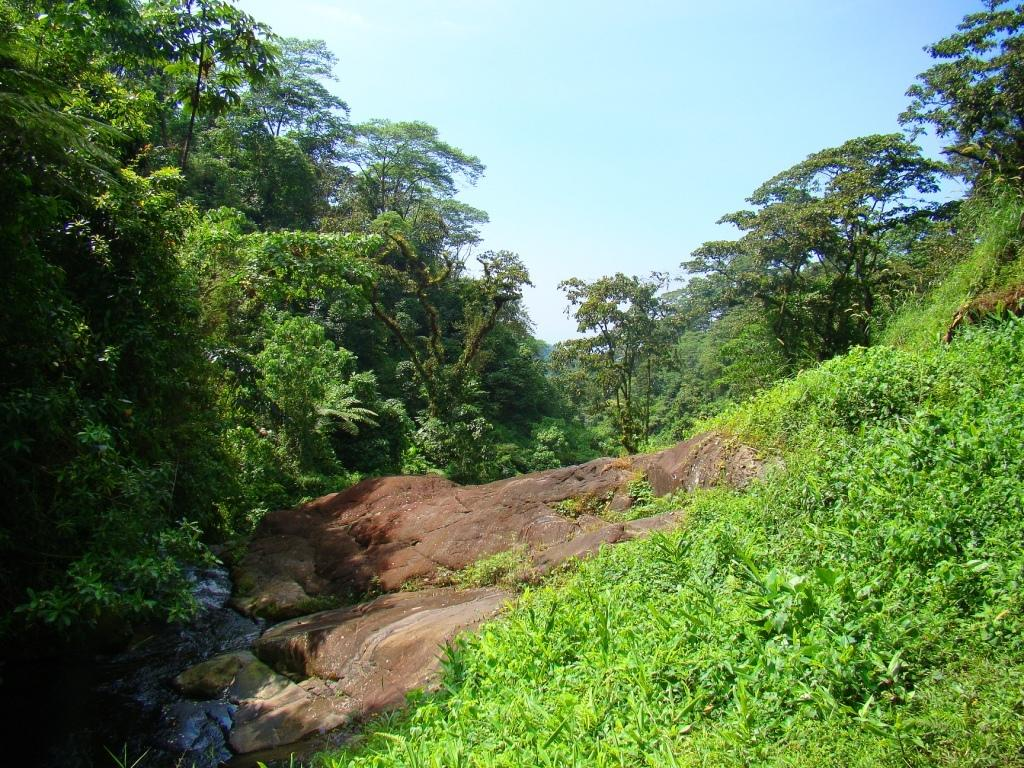What is located in the foreground of the image? There is stone and trees in the foreground of the image. What can be seen on the left side of the image? There appears to be water on the left side of the image. What is visible at the top of the image? The sky is visible at the top of the image. How many fans are visible in the image? There are no fans present in the image. What is the chance of finding a comb in the image? There is no mention of a comb in the image, so it cannot be determined if there is a chance of finding one. 